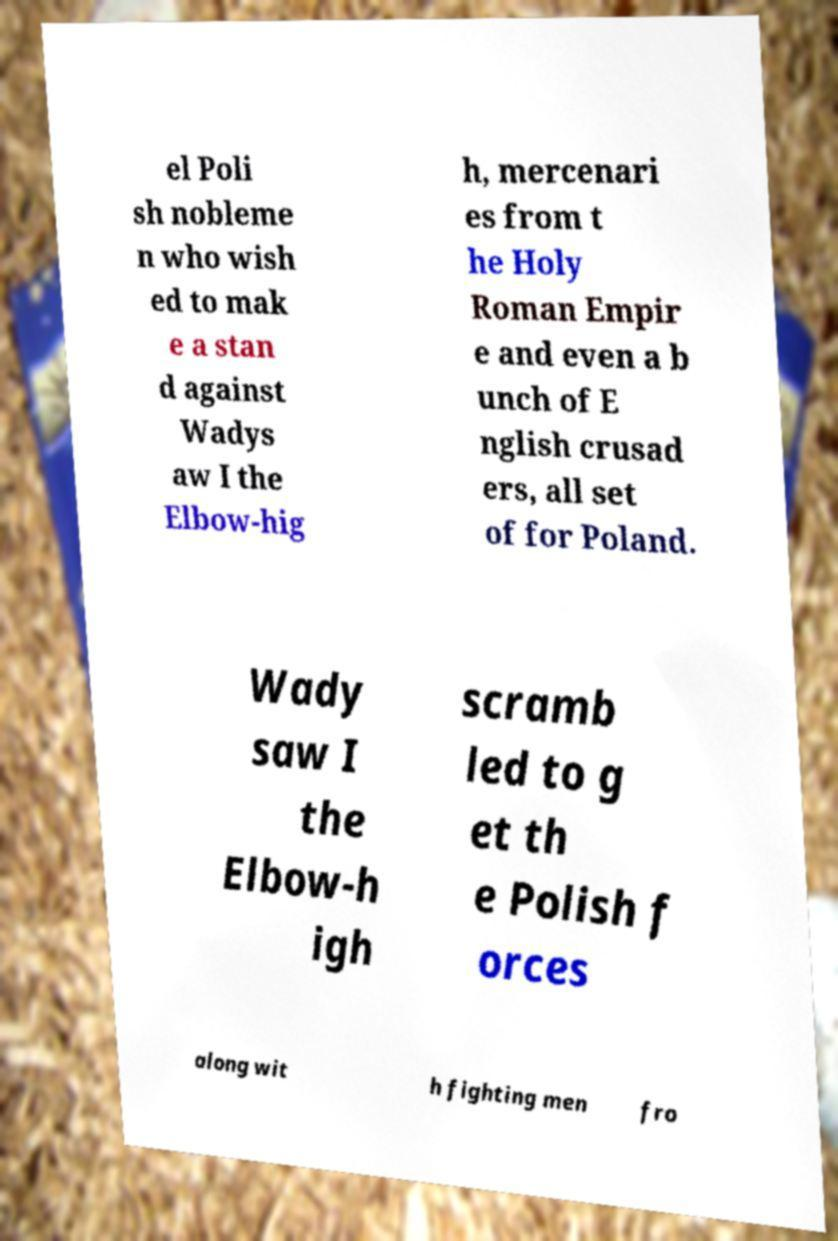Could you extract and type out the text from this image? el Poli sh nobleme n who wish ed to mak e a stan d against Wadys aw I the Elbow-hig h, mercenari es from t he Holy Roman Empir e and even a b unch of E nglish crusad ers, all set of for Poland. Wady saw I the Elbow-h igh scramb led to g et th e Polish f orces along wit h fighting men fro 